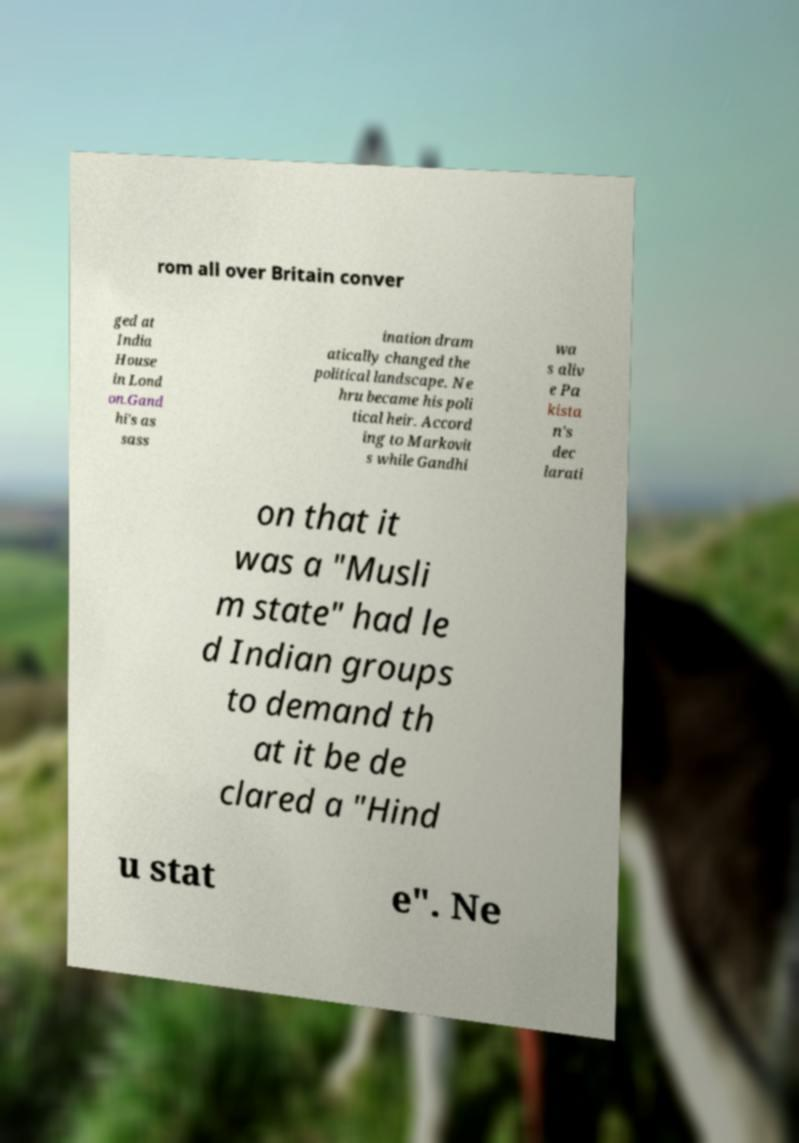I need the written content from this picture converted into text. Can you do that? rom all over Britain conver ged at India House in Lond on.Gand hi's as sass ination dram atically changed the political landscape. Ne hru became his poli tical heir. Accord ing to Markovit s while Gandhi wa s aliv e Pa kista n's dec larati on that it was a "Musli m state" had le d Indian groups to demand th at it be de clared a "Hind u stat e". Ne 